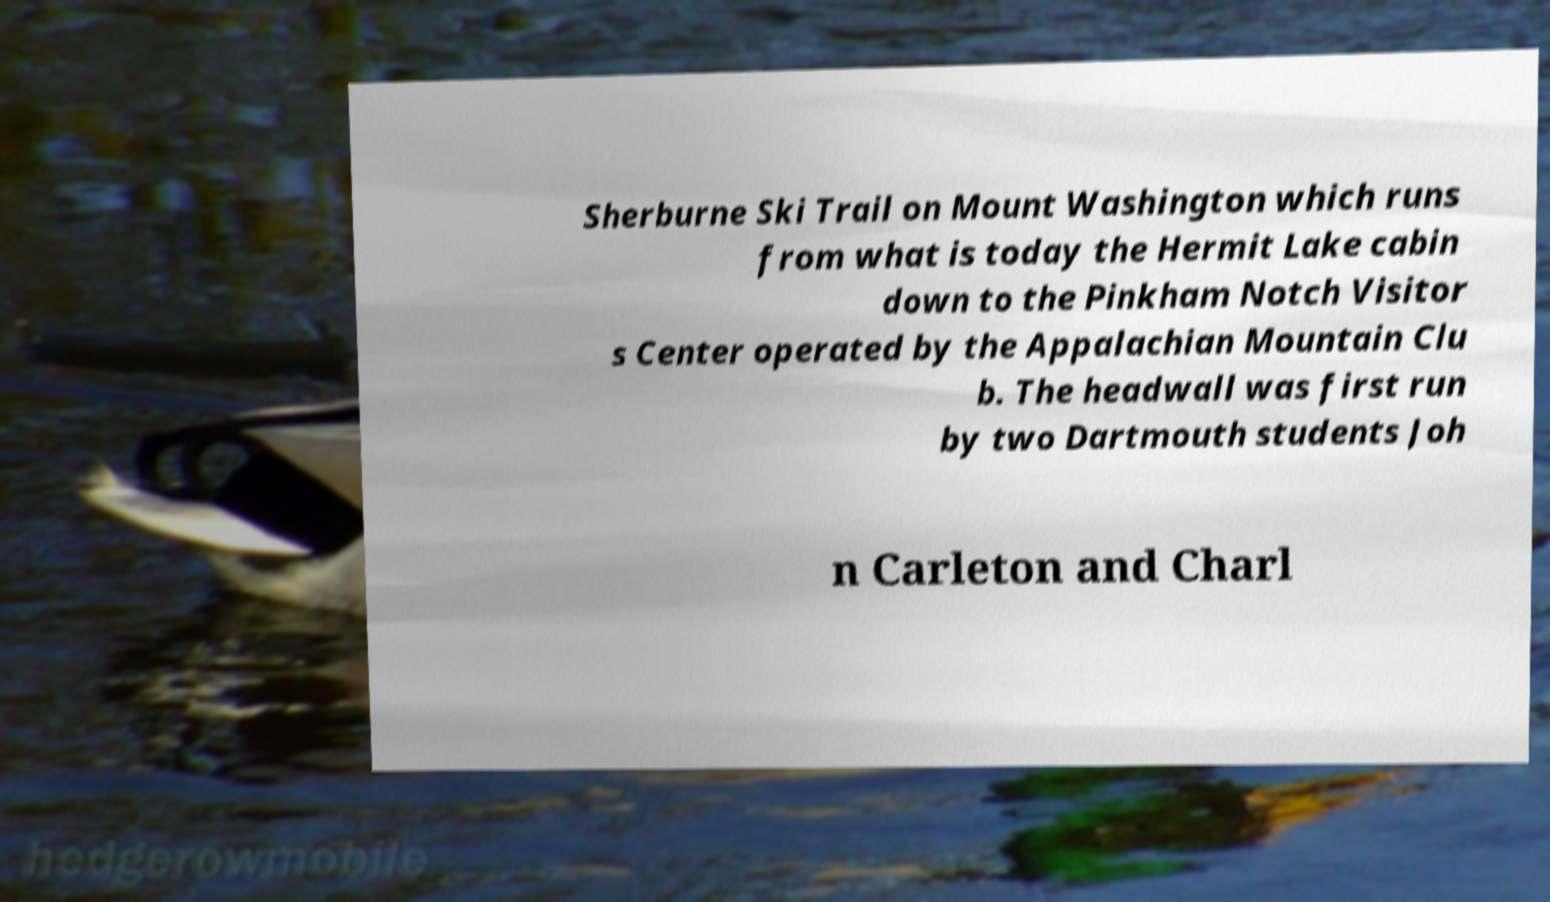Could you extract and type out the text from this image? Sherburne Ski Trail on Mount Washington which runs from what is today the Hermit Lake cabin down to the Pinkham Notch Visitor s Center operated by the Appalachian Mountain Clu b. The headwall was first run by two Dartmouth students Joh n Carleton and Charl 